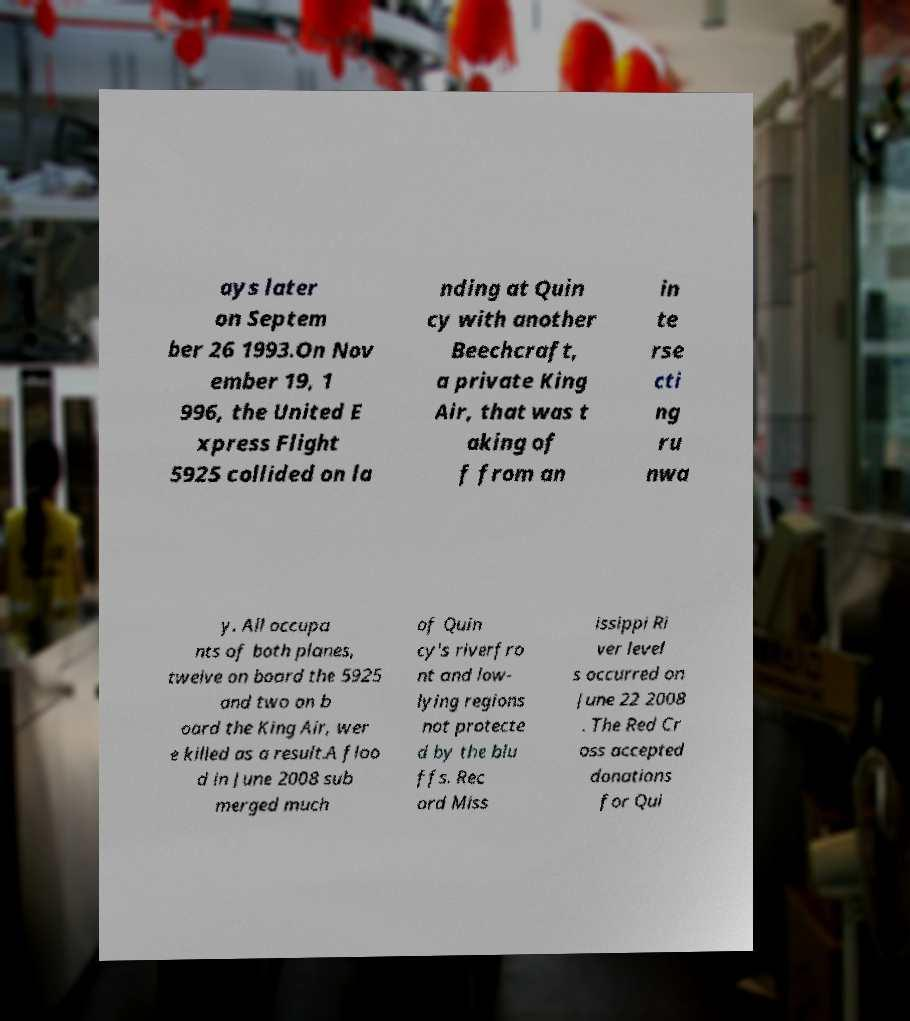For documentation purposes, I need the text within this image transcribed. Could you provide that? ays later on Septem ber 26 1993.On Nov ember 19, 1 996, the United E xpress Flight 5925 collided on la nding at Quin cy with another Beechcraft, a private King Air, that was t aking of f from an in te rse cti ng ru nwa y. All occupa nts of both planes, twelve on board the 5925 and two on b oard the King Air, wer e killed as a result.A floo d in June 2008 sub merged much of Quin cy's riverfro nt and low- lying regions not protecte d by the blu ffs. Rec ord Miss issippi Ri ver level s occurred on June 22 2008 . The Red Cr oss accepted donations for Qui 